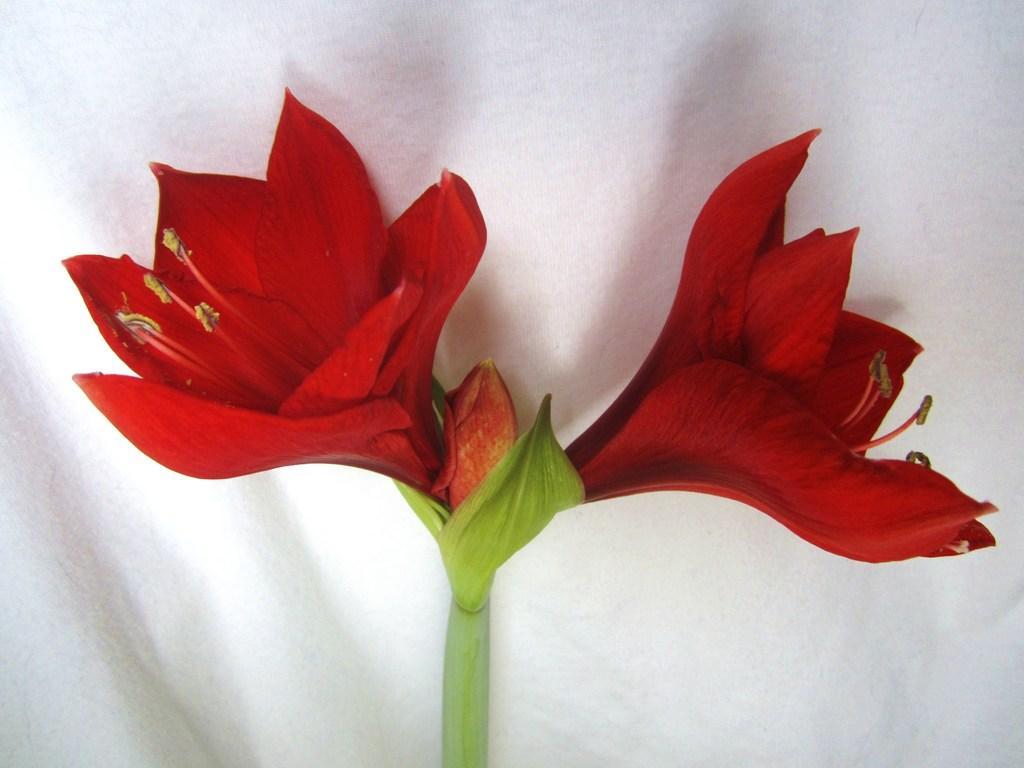Describe this image in one or two sentences. In the middle of the image there is a stem with two flowers and a bud and the flowers are dark red in color. In the background there is a white surface. It seems like a cloth. 